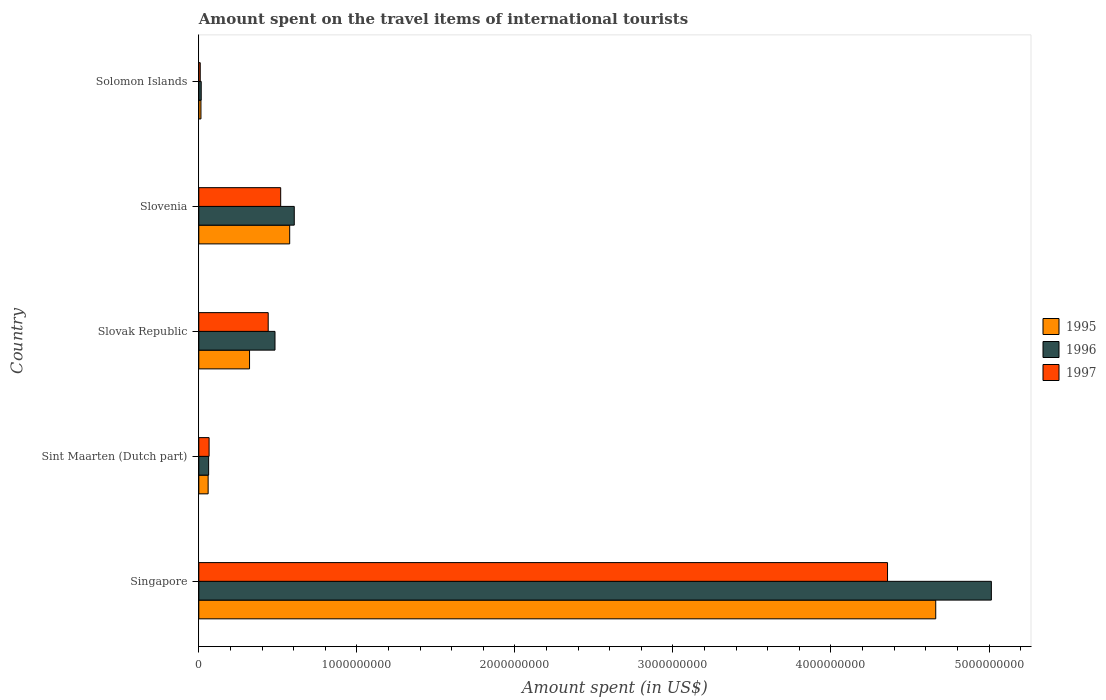Are the number of bars on each tick of the Y-axis equal?
Your answer should be compact. Yes. How many bars are there on the 2nd tick from the top?
Give a very brief answer. 3. How many bars are there on the 3rd tick from the bottom?
Offer a very short reply. 3. What is the label of the 1st group of bars from the top?
Offer a very short reply. Solomon Islands. In how many cases, is the number of bars for a given country not equal to the number of legend labels?
Offer a terse response. 0. What is the amount spent on the travel items of international tourists in 1996 in Sint Maarten (Dutch part)?
Give a very brief answer. 6.20e+07. Across all countries, what is the maximum amount spent on the travel items of international tourists in 1996?
Provide a succinct answer. 5.02e+09. Across all countries, what is the minimum amount spent on the travel items of international tourists in 1995?
Your response must be concise. 1.35e+07. In which country was the amount spent on the travel items of international tourists in 1995 maximum?
Keep it short and to the point. Singapore. In which country was the amount spent on the travel items of international tourists in 1995 minimum?
Ensure brevity in your answer.  Solomon Islands. What is the total amount spent on the travel items of international tourists in 1996 in the graph?
Provide a short and direct response. 6.18e+09. What is the difference between the amount spent on the travel items of international tourists in 1996 in Singapore and that in Solomon Islands?
Ensure brevity in your answer.  5.00e+09. What is the difference between the amount spent on the travel items of international tourists in 1997 in Slovak Republic and the amount spent on the travel items of international tourists in 1995 in Slovenia?
Make the answer very short. -1.36e+08. What is the average amount spent on the travel items of international tourists in 1996 per country?
Provide a short and direct response. 1.24e+09. What is the difference between the amount spent on the travel items of international tourists in 1996 and amount spent on the travel items of international tourists in 1997 in Singapore?
Your answer should be very brief. 6.57e+08. In how many countries, is the amount spent on the travel items of international tourists in 1997 greater than 4600000000 US$?
Provide a succinct answer. 0. What is the ratio of the amount spent on the travel items of international tourists in 1995 in Singapore to that in Slovak Republic?
Keep it short and to the point. 14.53. Is the amount spent on the travel items of international tourists in 1997 in Sint Maarten (Dutch part) less than that in Solomon Islands?
Provide a short and direct response. No. Is the difference between the amount spent on the travel items of international tourists in 1996 in Singapore and Slovak Republic greater than the difference between the amount spent on the travel items of international tourists in 1997 in Singapore and Slovak Republic?
Offer a terse response. Yes. What is the difference between the highest and the second highest amount spent on the travel items of international tourists in 1996?
Give a very brief answer. 4.41e+09. What is the difference between the highest and the lowest amount spent on the travel items of international tourists in 1997?
Your answer should be compact. 4.35e+09. In how many countries, is the amount spent on the travel items of international tourists in 1997 greater than the average amount spent on the travel items of international tourists in 1997 taken over all countries?
Make the answer very short. 1. What does the 1st bar from the bottom in Slovak Republic represents?
Your answer should be very brief. 1995. How many countries are there in the graph?
Provide a short and direct response. 5. What is the difference between two consecutive major ticks on the X-axis?
Offer a very short reply. 1.00e+09. Are the values on the major ticks of X-axis written in scientific E-notation?
Make the answer very short. No. How are the legend labels stacked?
Ensure brevity in your answer.  Vertical. What is the title of the graph?
Keep it short and to the point. Amount spent on the travel items of international tourists. What is the label or title of the X-axis?
Give a very brief answer. Amount spent (in US$). What is the label or title of the Y-axis?
Ensure brevity in your answer.  Country. What is the Amount spent (in US$) in 1995 in Singapore?
Provide a succinct answer. 4.66e+09. What is the Amount spent (in US$) of 1996 in Singapore?
Offer a very short reply. 5.02e+09. What is the Amount spent (in US$) in 1997 in Singapore?
Make the answer very short. 4.36e+09. What is the Amount spent (in US$) in 1995 in Sint Maarten (Dutch part)?
Offer a very short reply. 5.90e+07. What is the Amount spent (in US$) of 1996 in Sint Maarten (Dutch part)?
Ensure brevity in your answer.  6.20e+07. What is the Amount spent (in US$) in 1997 in Sint Maarten (Dutch part)?
Your response must be concise. 6.50e+07. What is the Amount spent (in US$) of 1995 in Slovak Republic?
Keep it short and to the point. 3.21e+08. What is the Amount spent (in US$) in 1996 in Slovak Republic?
Your answer should be very brief. 4.82e+08. What is the Amount spent (in US$) in 1997 in Slovak Republic?
Your response must be concise. 4.39e+08. What is the Amount spent (in US$) in 1995 in Slovenia?
Provide a succinct answer. 5.75e+08. What is the Amount spent (in US$) in 1996 in Slovenia?
Your answer should be very brief. 6.04e+08. What is the Amount spent (in US$) in 1997 in Slovenia?
Provide a succinct answer. 5.18e+08. What is the Amount spent (in US$) in 1995 in Solomon Islands?
Give a very brief answer. 1.35e+07. What is the Amount spent (in US$) of 1996 in Solomon Islands?
Provide a succinct answer. 1.52e+07. What is the Amount spent (in US$) of 1997 in Solomon Islands?
Make the answer very short. 9.00e+06. Across all countries, what is the maximum Amount spent (in US$) of 1995?
Give a very brief answer. 4.66e+09. Across all countries, what is the maximum Amount spent (in US$) of 1996?
Provide a succinct answer. 5.02e+09. Across all countries, what is the maximum Amount spent (in US$) in 1997?
Make the answer very short. 4.36e+09. Across all countries, what is the minimum Amount spent (in US$) of 1995?
Keep it short and to the point. 1.35e+07. Across all countries, what is the minimum Amount spent (in US$) in 1996?
Your response must be concise. 1.52e+07. Across all countries, what is the minimum Amount spent (in US$) in 1997?
Your response must be concise. 9.00e+06. What is the total Amount spent (in US$) of 1995 in the graph?
Offer a very short reply. 5.63e+09. What is the total Amount spent (in US$) of 1996 in the graph?
Provide a succinct answer. 6.18e+09. What is the total Amount spent (in US$) of 1997 in the graph?
Your answer should be very brief. 5.39e+09. What is the difference between the Amount spent (in US$) of 1995 in Singapore and that in Sint Maarten (Dutch part)?
Give a very brief answer. 4.60e+09. What is the difference between the Amount spent (in US$) of 1996 in Singapore and that in Sint Maarten (Dutch part)?
Give a very brief answer. 4.95e+09. What is the difference between the Amount spent (in US$) in 1997 in Singapore and that in Sint Maarten (Dutch part)?
Ensure brevity in your answer.  4.29e+09. What is the difference between the Amount spent (in US$) of 1995 in Singapore and that in Slovak Republic?
Your answer should be very brief. 4.34e+09. What is the difference between the Amount spent (in US$) in 1996 in Singapore and that in Slovak Republic?
Your response must be concise. 4.53e+09. What is the difference between the Amount spent (in US$) of 1997 in Singapore and that in Slovak Republic?
Your answer should be very brief. 3.92e+09. What is the difference between the Amount spent (in US$) of 1995 in Singapore and that in Slovenia?
Your response must be concise. 4.09e+09. What is the difference between the Amount spent (in US$) of 1996 in Singapore and that in Slovenia?
Keep it short and to the point. 4.41e+09. What is the difference between the Amount spent (in US$) in 1997 in Singapore and that in Slovenia?
Offer a very short reply. 3.84e+09. What is the difference between the Amount spent (in US$) of 1995 in Singapore and that in Solomon Islands?
Offer a terse response. 4.65e+09. What is the difference between the Amount spent (in US$) of 1996 in Singapore and that in Solomon Islands?
Your answer should be very brief. 5.00e+09. What is the difference between the Amount spent (in US$) in 1997 in Singapore and that in Solomon Islands?
Make the answer very short. 4.35e+09. What is the difference between the Amount spent (in US$) in 1995 in Sint Maarten (Dutch part) and that in Slovak Republic?
Ensure brevity in your answer.  -2.62e+08. What is the difference between the Amount spent (in US$) in 1996 in Sint Maarten (Dutch part) and that in Slovak Republic?
Your answer should be very brief. -4.20e+08. What is the difference between the Amount spent (in US$) of 1997 in Sint Maarten (Dutch part) and that in Slovak Republic?
Provide a succinct answer. -3.74e+08. What is the difference between the Amount spent (in US$) of 1995 in Sint Maarten (Dutch part) and that in Slovenia?
Your answer should be very brief. -5.16e+08. What is the difference between the Amount spent (in US$) of 1996 in Sint Maarten (Dutch part) and that in Slovenia?
Offer a very short reply. -5.42e+08. What is the difference between the Amount spent (in US$) in 1997 in Sint Maarten (Dutch part) and that in Slovenia?
Make the answer very short. -4.53e+08. What is the difference between the Amount spent (in US$) of 1995 in Sint Maarten (Dutch part) and that in Solomon Islands?
Offer a terse response. 4.55e+07. What is the difference between the Amount spent (in US$) in 1996 in Sint Maarten (Dutch part) and that in Solomon Islands?
Give a very brief answer. 4.68e+07. What is the difference between the Amount spent (in US$) in 1997 in Sint Maarten (Dutch part) and that in Solomon Islands?
Make the answer very short. 5.60e+07. What is the difference between the Amount spent (in US$) in 1995 in Slovak Republic and that in Slovenia?
Offer a very short reply. -2.54e+08. What is the difference between the Amount spent (in US$) in 1996 in Slovak Republic and that in Slovenia?
Your answer should be compact. -1.22e+08. What is the difference between the Amount spent (in US$) in 1997 in Slovak Republic and that in Slovenia?
Your answer should be compact. -7.90e+07. What is the difference between the Amount spent (in US$) in 1995 in Slovak Republic and that in Solomon Islands?
Provide a short and direct response. 3.08e+08. What is the difference between the Amount spent (in US$) of 1996 in Slovak Republic and that in Solomon Islands?
Offer a very short reply. 4.67e+08. What is the difference between the Amount spent (in US$) in 1997 in Slovak Republic and that in Solomon Islands?
Provide a short and direct response. 4.30e+08. What is the difference between the Amount spent (in US$) in 1995 in Slovenia and that in Solomon Islands?
Provide a succinct answer. 5.62e+08. What is the difference between the Amount spent (in US$) of 1996 in Slovenia and that in Solomon Islands?
Make the answer very short. 5.89e+08. What is the difference between the Amount spent (in US$) in 1997 in Slovenia and that in Solomon Islands?
Give a very brief answer. 5.09e+08. What is the difference between the Amount spent (in US$) of 1995 in Singapore and the Amount spent (in US$) of 1996 in Sint Maarten (Dutch part)?
Offer a terse response. 4.60e+09. What is the difference between the Amount spent (in US$) of 1995 in Singapore and the Amount spent (in US$) of 1997 in Sint Maarten (Dutch part)?
Give a very brief answer. 4.60e+09. What is the difference between the Amount spent (in US$) of 1996 in Singapore and the Amount spent (in US$) of 1997 in Sint Maarten (Dutch part)?
Make the answer very short. 4.95e+09. What is the difference between the Amount spent (in US$) of 1995 in Singapore and the Amount spent (in US$) of 1996 in Slovak Republic?
Your response must be concise. 4.18e+09. What is the difference between the Amount spent (in US$) in 1995 in Singapore and the Amount spent (in US$) in 1997 in Slovak Republic?
Your answer should be compact. 4.22e+09. What is the difference between the Amount spent (in US$) in 1996 in Singapore and the Amount spent (in US$) in 1997 in Slovak Republic?
Your response must be concise. 4.58e+09. What is the difference between the Amount spent (in US$) of 1995 in Singapore and the Amount spent (in US$) of 1996 in Slovenia?
Offer a very short reply. 4.06e+09. What is the difference between the Amount spent (in US$) of 1995 in Singapore and the Amount spent (in US$) of 1997 in Slovenia?
Your answer should be compact. 4.14e+09. What is the difference between the Amount spent (in US$) of 1996 in Singapore and the Amount spent (in US$) of 1997 in Slovenia?
Provide a short and direct response. 4.50e+09. What is the difference between the Amount spent (in US$) of 1995 in Singapore and the Amount spent (in US$) of 1996 in Solomon Islands?
Your answer should be very brief. 4.65e+09. What is the difference between the Amount spent (in US$) in 1995 in Singapore and the Amount spent (in US$) in 1997 in Solomon Islands?
Provide a short and direct response. 4.65e+09. What is the difference between the Amount spent (in US$) of 1996 in Singapore and the Amount spent (in US$) of 1997 in Solomon Islands?
Keep it short and to the point. 5.01e+09. What is the difference between the Amount spent (in US$) of 1995 in Sint Maarten (Dutch part) and the Amount spent (in US$) of 1996 in Slovak Republic?
Ensure brevity in your answer.  -4.23e+08. What is the difference between the Amount spent (in US$) in 1995 in Sint Maarten (Dutch part) and the Amount spent (in US$) in 1997 in Slovak Republic?
Ensure brevity in your answer.  -3.80e+08. What is the difference between the Amount spent (in US$) of 1996 in Sint Maarten (Dutch part) and the Amount spent (in US$) of 1997 in Slovak Republic?
Your response must be concise. -3.77e+08. What is the difference between the Amount spent (in US$) of 1995 in Sint Maarten (Dutch part) and the Amount spent (in US$) of 1996 in Slovenia?
Offer a terse response. -5.45e+08. What is the difference between the Amount spent (in US$) of 1995 in Sint Maarten (Dutch part) and the Amount spent (in US$) of 1997 in Slovenia?
Make the answer very short. -4.59e+08. What is the difference between the Amount spent (in US$) in 1996 in Sint Maarten (Dutch part) and the Amount spent (in US$) in 1997 in Slovenia?
Offer a very short reply. -4.56e+08. What is the difference between the Amount spent (in US$) of 1995 in Sint Maarten (Dutch part) and the Amount spent (in US$) of 1996 in Solomon Islands?
Provide a short and direct response. 4.38e+07. What is the difference between the Amount spent (in US$) of 1995 in Sint Maarten (Dutch part) and the Amount spent (in US$) of 1997 in Solomon Islands?
Provide a succinct answer. 5.00e+07. What is the difference between the Amount spent (in US$) in 1996 in Sint Maarten (Dutch part) and the Amount spent (in US$) in 1997 in Solomon Islands?
Your answer should be very brief. 5.30e+07. What is the difference between the Amount spent (in US$) in 1995 in Slovak Republic and the Amount spent (in US$) in 1996 in Slovenia?
Provide a short and direct response. -2.83e+08. What is the difference between the Amount spent (in US$) in 1995 in Slovak Republic and the Amount spent (in US$) in 1997 in Slovenia?
Your response must be concise. -1.97e+08. What is the difference between the Amount spent (in US$) in 1996 in Slovak Republic and the Amount spent (in US$) in 1997 in Slovenia?
Give a very brief answer. -3.60e+07. What is the difference between the Amount spent (in US$) of 1995 in Slovak Republic and the Amount spent (in US$) of 1996 in Solomon Islands?
Keep it short and to the point. 3.06e+08. What is the difference between the Amount spent (in US$) in 1995 in Slovak Republic and the Amount spent (in US$) in 1997 in Solomon Islands?
Your answer should be very brief. 3.12e+08. What is the difference between the Amount spent (in US$) of 1996 in Slovak Republic and the Amount spent (in US$) of 1997 in Solomon Islands?
Provide a succinct answer. 4.73e+08. What is the difference between the Amount spent (in US$) of 1995 in Slovenia and the Amount spent (in US$) of 1996 in Solomon Islands?
Offer a very short reply. 5.60e+08. What is the difference between the Amount spent (in US$) of 1995 in Slovenia and the Amount spent (in US$) of 1997 in Solomon Islands?
Provide a succinct answer. 5.66e+08. What is the difference between the Amount spent (in US$) in 1996 in Slovenia and the Amount spent (in US$) in 1997 in Solomon Islands?
Offer a very short reply. 5.95e+08. What is the average Amount spent (in US$) in 1995 per country?
Make the answer very short. 1.13e+09. What is the average Amount spent (in US$) in 1996 per country?
Provide a succinct answer. 1.24e+09. What is the average Amount spent (in US$) in 1997 per country?
Keep it short and to the point. 1.08e+09. What is the difference between the Amount spent (in US$) in 1995 and Amount spent (in US$) in 1996 in Singapore?
Give a very brief answer. -3.52e+08. What is the difference between the Amount spent (in US$) in 1995 and Amount spent (in US$) in 1997 in Singapore?
Your answer should be compact. 3.05e+08. What is the difference between the Amount spent (in US$) of 1996 and Amount spent (in US$) of 1997 in Singapore?
Provide a succinct answer. 6.57e+08. What is the difference between the Amount spent (in US$) in 1995 and Amount spent (in US$) in 1997 in Sint Maarten (Dutch part)?
Your response must be concise. -6.00e+06. What is the difference between the Amount spent (in US$) of 1996 and Amount spent (in US$) of 1997 in Sint Maarten (Dutch part)?
Offer a very short reply. -3.00e+06. What is the difference between the Amount spent (in US$) of 1995 and Amount spent (in US$) of 1996 in Slovak Republic?
Your response must be concise. -1.61e+08. What is the difference between the Amount spent (in US$) of 1995 and Amount spent (in US$) of 1997 in Slovak Republic?
Provide a succinct answer. -1.18e+08. What is the difference between the Amount spent (in US$) of 1996 and Amount spent (in US$) of 1997 in Slovak Republic?
Give a very brief answer. 4.30e+07. What is the difference between the Amount spent (in US$) in 1995 and Amount spent (in US$) in 1996 in Slovenia?
Your response must be concise. -2.90e+07. What is the difference between the Amount spent (in US$) in 1995 and Amount spent (in US$) in 1997 in Slovenia?
Offer a terse response. 5.70e+07. What is the difference between the Amount spent (in US$) of 1996 and Amount spent (in US$) of 1997 in Slovenia?
Provide a succinct answer. 8.60e+07. What is the difference between the Amount spent (in US$) in 1995 and Amount spent (in US$) in 1996 in Solomon Islands?
Your answer should be compact. -1.70e+06. What is the difference between the Amount spent (in US$) in 1995 and Amount spent (in US$) in 1997 in Solomon Islands?
Offer a terse response. 4.50e+06. What is the difference between the Amount spent (in US$) of 1996 and Amount spent (in US$) of 1997 in Solomon Islands?
Provide a succinct answer. 6.20e+06. What is the ratio of the Amount spent (in US$) of 1995 in Singapore to that in Sint Maarten (Dutch part)?
Offer a terse response. 79.03. What is the ratio of the Amount spent (in US$) of 1996 in Singapore to that in Sint Maarten (Dutch part)?
Offer a terse response. 80.89. What is the ratio of the Amount spent (in US$) in 1997 in Singapore to that in Sint Maarten (Dutch part)?
Keep it short and to the point. 67.05. What is the ratio of the Amount spent (in US$) of 1995 in Singapore to that in Slovak Republic?
Ensure brevity in your answer.  14.53. What is the ratio of the Amount spent (in US$) in 1996 in Singapore to that in Slovak Republic?
Provide a succinct answer. 10.4. What is the ratio of the Amount spent (in US$) in 1997 in Singapore to that in Slovak Republic?
Your answer should be very brief. 9.93. What is the ratio of the Amount spent (in US$) in 1995 in Singapore to that in Slovenia?
Offer a very short reply. 8.11. What is the ratio of the Amount spent (in US$) in 1996 in Singapore to that in Slovenia?
Your answer should be compact. 8.3. What is the ratio of the Amount spent (in US$) in 1997 in Singapore to that in Slovenia?
Keep it short and to the point. 8.41. What is the ratio of the Amount spent (in US$) of 1995 in Singapore to that in Solomon Islands?
Keep it short and to the point. 345.41. What is the ratio of the Amount spent (in US$) of 1996 in Singapore to that in Solomon Islands?
Offer a terse response. 329.93. What is the ratio of the Amount spent (in US$) in 1997 in Singapore to that in Solomon Islands?
Offer a very short reply. 484.22. What is the ratio of the Amount spent (in US$) of 1995 in Sint Maarten (Dutch part) to that in Slovak Republic?
Offer a terse response. 0.18. What is the ratio of the Amount spent (in US$) of 1996 in Sint Maarten (Dutch part) to that in Slovak Republic?
Your response must be concise. 0.13. What is the ratio of the Amount spent (in US$) in 1997 in Sint Maarten (Dutch part) to that in Slovak Republic?
Make the answer very short. 0.15. What is the ratio of the Amount spent (in US$) in 1995 in Sint Maarten (Dutch part) to that in Slovenia?
Make the answer very short. 0.1. What is the ratio of the Amount spent (in US$) of 1996 in Sint Maarten (Dutch part) to that in Slovenia?
Ensure brevity in your answer.  0.1. What is the ratio of the Amount spent (in US$) in 1997 in Sint Maarten (Dutch part) to that in Slovenia?
Provide a short and direct response. 0.13. What is the ratio of the Amount spent (in US$) of 1995 in Sint Maarten (Dutch part) to that in Solomon Islands?
Make the answer very short. 4.37. What is the ratio of the Amount spent (in US$) in 1996 in Sint Maarten (Dutch part) to that in Solomon Islands?
Your answer should be compact. 4.08. What is the ratio of the Amount spent (in US$) in 1997 in Sint Maarten (Dutch part) to that in Solomon Islands?
Give a very brief answer. 7.22. What is the ratio of the Amount spent (in US$) in 1995 in Slovak Republic to that in Slovenia?
Your response must be concise. 0.56. What is the ratio of the Amount spent (in US$) of 1996 in Slovak Republic to that in Slovenia?
Offer a very short reply. 0.8. What is the ratio of the Amount spent (in US$) of 1997 in Slovak Republic to that in Slovenia?
Provide a succinct answer. 0.85. What is the ratio of the Amount spent (in US$) of 1995 in Slovak Republic to that in Solomon Islands?
Offer a terse response. 23.78. What is the ratio of the Amount spent (in US$) of 1996 in Slovak Republic to that in Solomon Islands?
Keep it short and to the point. 31.71. What is the ratio of the Amount spent (in US$) of 1997 in Slovak Republic to that in Solomon Islands?
Your answer should be compact. 48.78. What is the ratio of the Amount spent (in US$) in 1995 in Slovenia to that in Solomon Islands?
Your answer should be very brief. 42.59. What is the ratio of the Amount spent (in US$) of 1996 in Slovenia to that in Solomon Islands?
Your answer should be compact. 39.74. What is the ratio of the Amount spent (in US$) in 1997 in Slovenia to that in Solomon Islands?
Offer a terse response. 57.56. What is the difference between the highest and the second highest Amount spent (in US$) of 1995?
Your answer should be compact. 4.09e+09. What is the difference between the highest and the second highest Amount spent (in US$) in 1996?
Give a very brief answer. 4.41e+09. What is the difference between the highest and the second highest Amount spent (in US$) in 1997?
Keep it short and to the point. 3.84e+09. What is the difference between the highest and the lowest Amount spent (in US$) in 1995?
Offer a very short reply. 4.65e+09. What is the difference between the highest and the lowest Amount spent (in US$) of 1996?
Your response must be concise. 5.00e+09. What is the difference between the highest and the lowest Amount spent (in US$) in 1997?
Provide a succinct answer. 4.35e+09. 